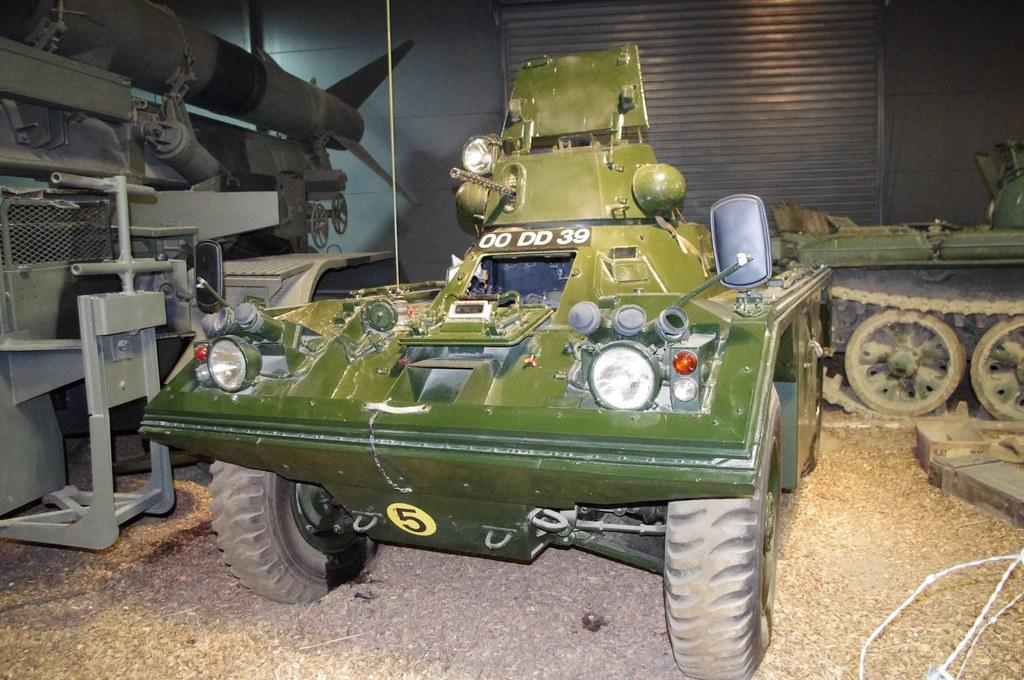What is the main subject of the image? There is a vehicle in the image. Where is the vehicle located? The vehicle is on the ground. What can be seen in the background of the image? There is a shutter and a wall in the background of the image. What part of the vehicle is visible in the background? There are wheels visible in the background of the image. What type of vest is the vehicle wearing in the image? There is no vest present in the image, as vehicles do not wear clothing. 